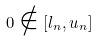Convert formula to latex. <formula><loc_0><loc_0><loc_500><loc_500>0 \notin [ l _ { n } , u _ { n } ]</formula> 